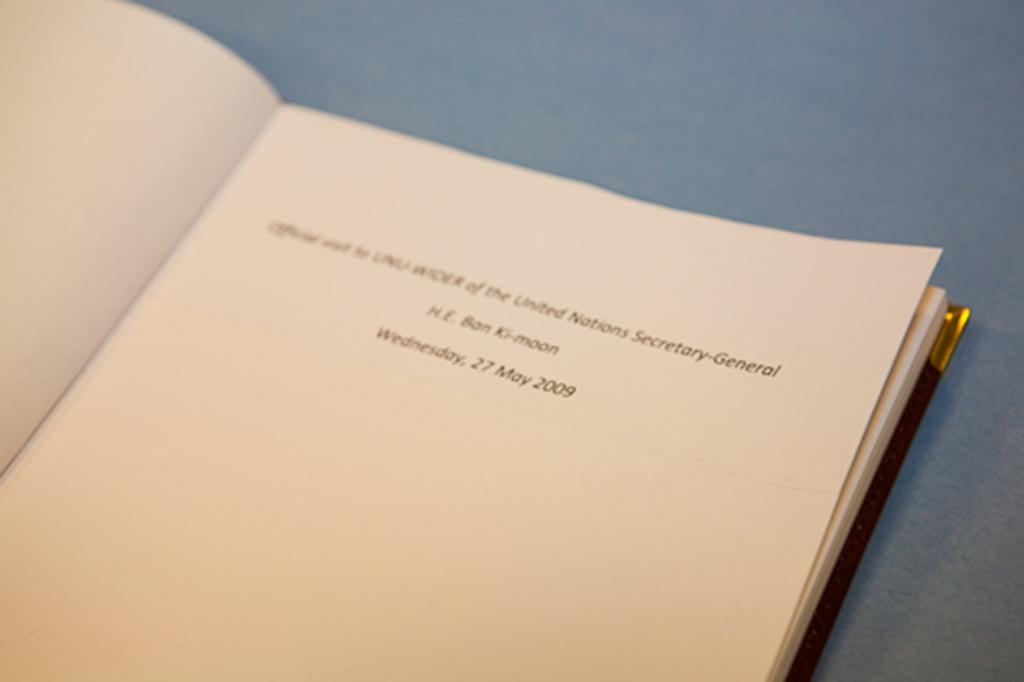<image>
Describe the image concisely. A white page in a book mentions the date of Wednesday 27 May 2009. 